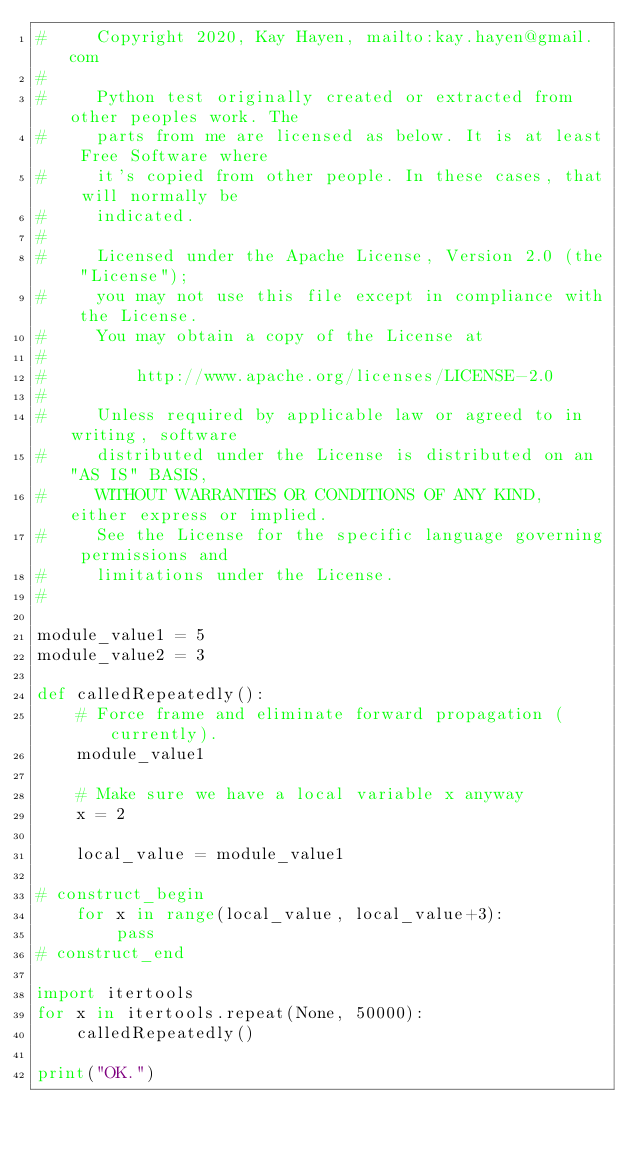Convert code to text. <code><loc_0><loc_0><loc_500><loc_500><_Python_>#     Copyright 2020, Kay Hayen, mailto:kay.hayen@gmail.com
#
#     Python test originally created or extracted from other peoples work. The
#     parts from me are licensed as below. It is at least Free Software where
#     it's copied from other people. In these cases, that will normally be
#     indicated.
#
#     Licensed under the Apache License, Version 2.0 (the "License");
#     you may not use this file except in compliance with the License.
#     You may obtain a copy of the License at
#
#         http://www.apache.org/licenses/LICENSE-2.0
#
#     Unless required by applicable law or agreed to in writing, software
#     distributed under the License is distributed on an "AS IS" BASIS,
#     WITHOUT WARRANTIES OR CONDITIONS OF ANY KIND, either express or implied.
#     See the License for the specific language governing permissions and
#     limitations under the License.
#

module_value1 = 5
module_value2 = 3

def calledRepeatedly():
    # Force frame and eliminate forward propagation (currently).
    module_value1

    # Make sure we have a local variable x anyway
    x = 2

    local_value = module_value1

# construct_begin
    for x in range(local_value, local_value+3):
        pass
# construct_end

import itertools
for x in itertools.repeat(None, 50000):
    calledRepeatedly()

print("OK.")
</code> 